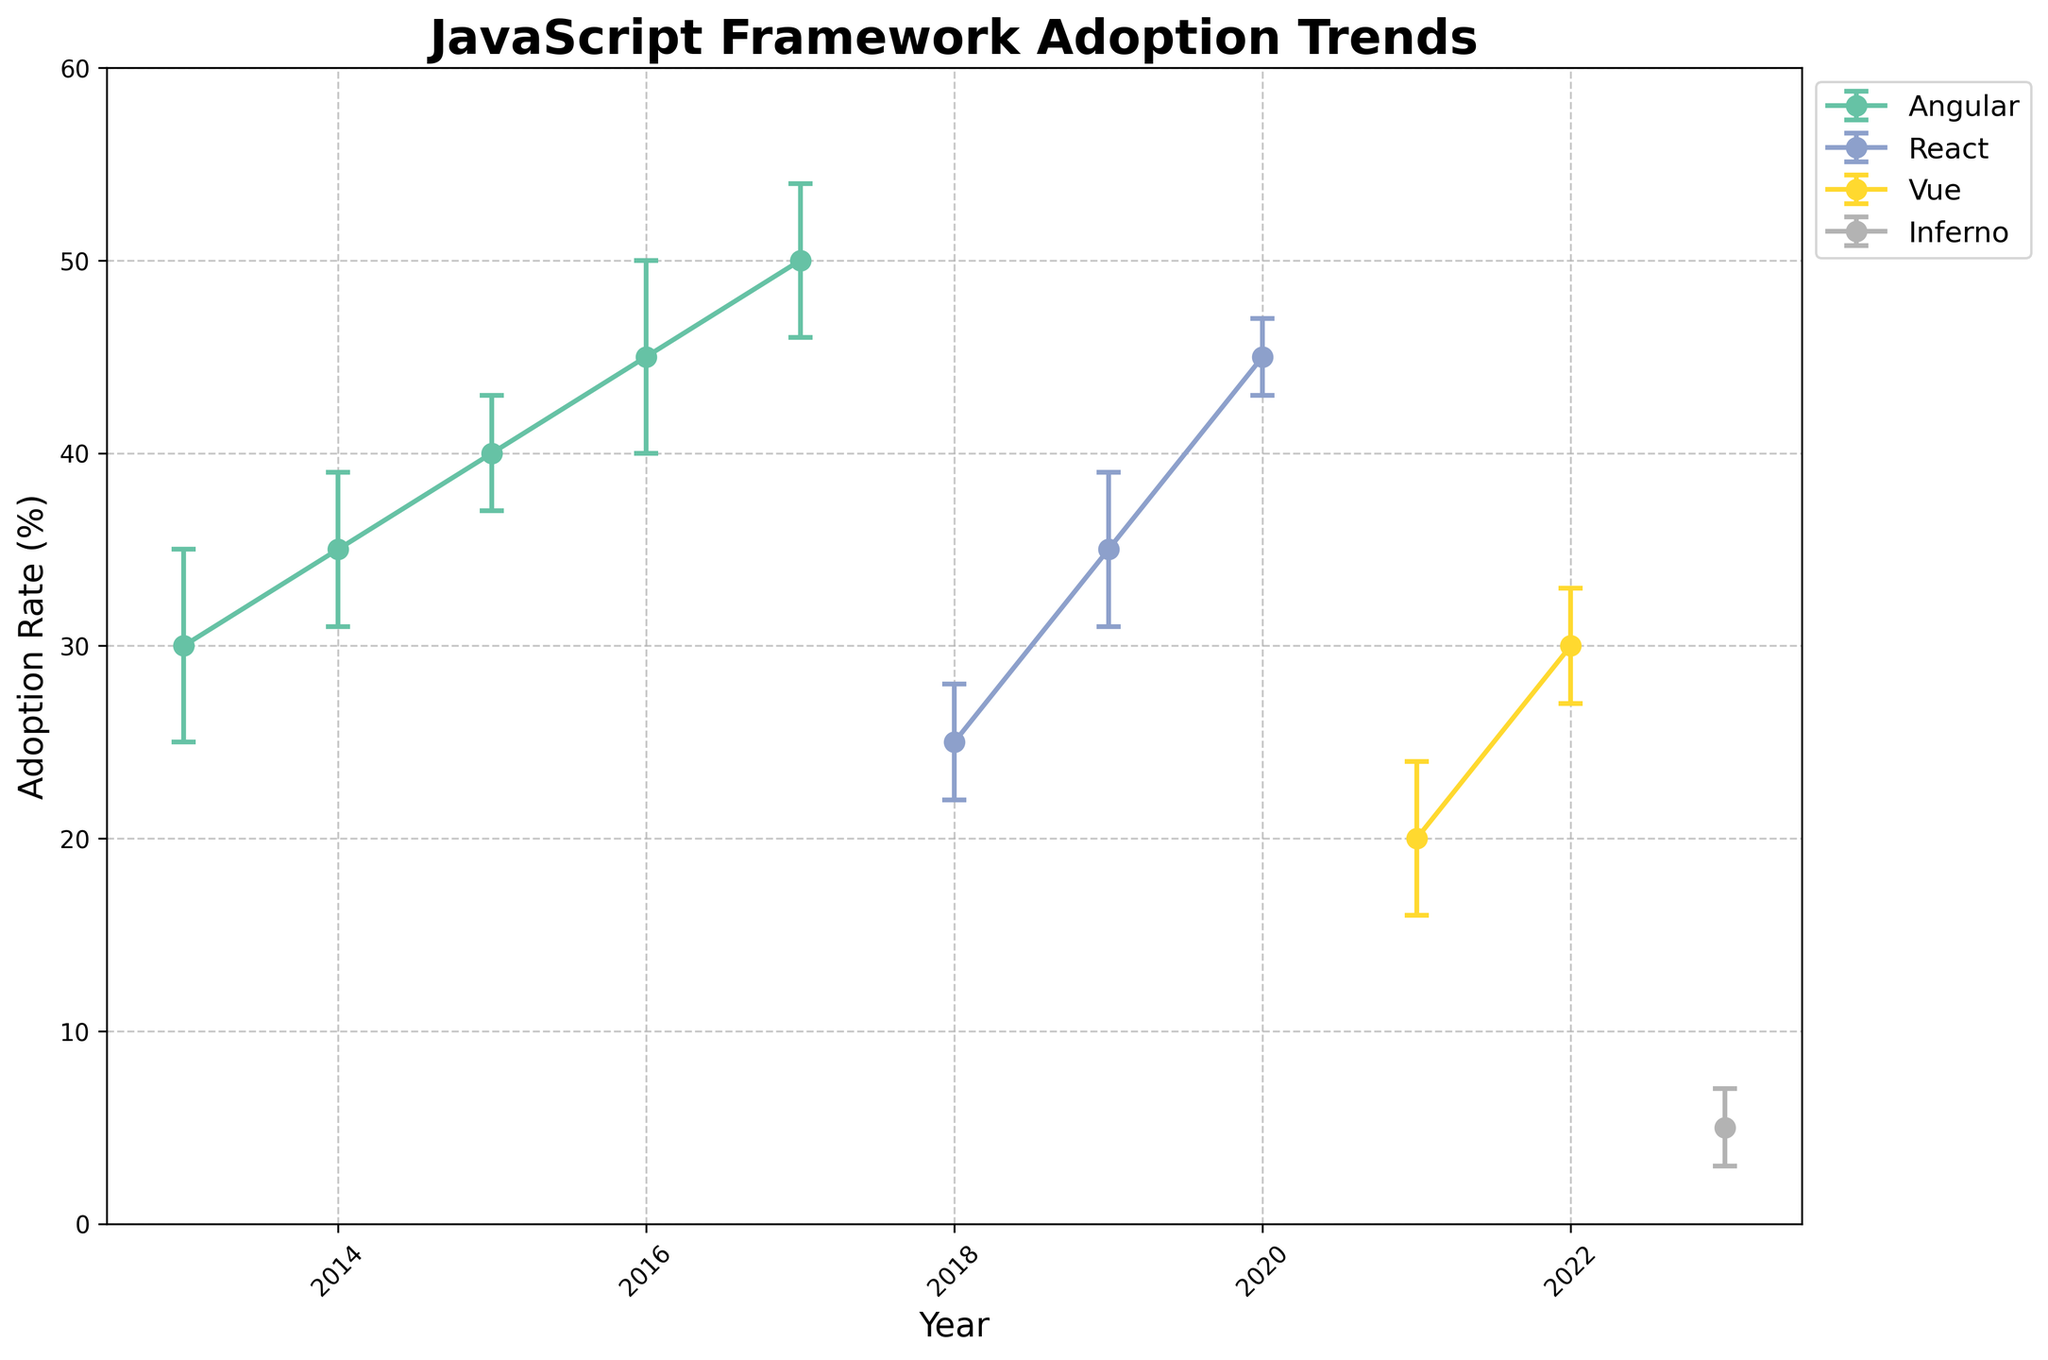What is the title of the plot? The title of the plot is located at the top, usually in bold and larger font size compared to other text in the figure. Here, it reads "JavaScript Framework Adoption Trends".
Answer: JavaScript Framework Adoption Trends Which framework had the highest adoption rate in 2017? Look for the year 2017 on the x-axis and identify which framework reached the highest percentage on the y-axis for that year. Angular, with version 4.0, had the highest adoption rate of 50%.
Answer: Angular How many frameworks are displayed in the plot? Different frameworks are usually distinguished by different colors and labels in the legend. In this plot, the legend shows four labels: Angular, React, Vue, and Inferno.
Answer: Four During which years did the adoption rate of React increase? Observe the line plot associated with React. From 2018 to 2020, the adoption rate for React increased from 25% to 45%. This shows a consistent upward trend during these years.
Answer: 2018 to 2020 Which framework was adopted the least in the most recent year shown? Refer to the data for the year 2023 and observe the corresponding adoption rates for each framework. Inferno had the lowest adoption rate of 5% in 2023.
Answer: Inferno What is the error margin for Vue in 2021? Locate the data point for Vue in 2021. The error bars visually show the uncertainty, represented as ±4%.
Answer: ±4% Which framework's adoption rate exceeded 45% at any point? Review the y-axis to find adoption rates above 45%. Angular surpassed this threshold in 2016 and 2017 with 45% and 50%, respectively.
Answer: Angular Compare the adoption rates of Angular and React in 2019. Which one is higher and by how much? Locate the data points for Angular and React in 2019. Angular's adoption rate was not mentioned for this year, thus React's rate (35%) is implicitly higher, with no computed difference.
Answer: React by 35% What is the trend for Vue's adoption rate from 2021 to 2022? Observe the data points for Vue in both years. There is a positive trend, as Vue's adoption rate increased from 20% in 2021 to 30% in 2022.
Answer: Increasing What's the average adoption rate of Angular from 2013 to 2017? Calculate the mean by summing the adoption rates (30, 35, 40, 45, 50) and dividing by the number of years (5). The sum is 200, so the average is 200 / 5 = 40%.
Answer: 40% 